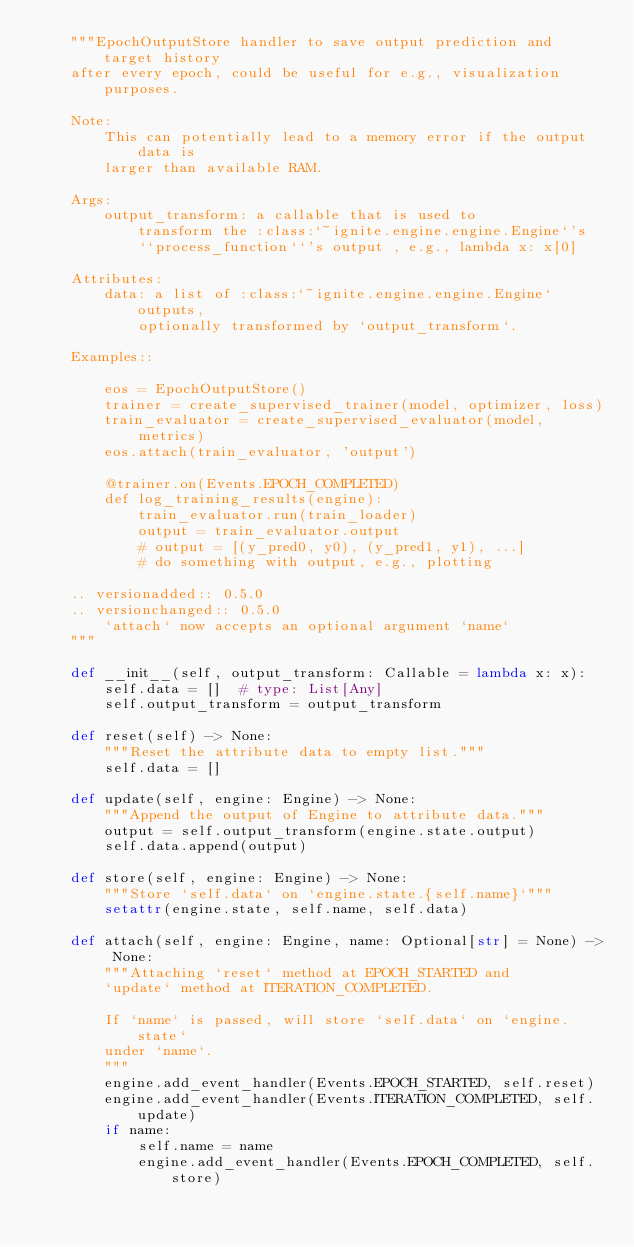<code> <loc_0><loc_0><loc_500><loc_500><_Python_>    """EpochOutputStore handler to save output prediction and target history
    after every epoch, could be useful for e.g., visualization purposes.

    Note:
        This can potentially lead to a memory error if the output data is
        larger than available RAM.

    Args:
        output_transform: a callable that is used to
            transform the :class:`~ignite.engine.engine.Engine`'s
            ``process_function``'s output , e.g., lambda x: x[0]

    Attributes:
        data: a list of :class:`~ignite.engine.engine.Engine` outputs,
            optionally transformed by `output_transform`.

    Examples::

        eos = EpochOutputStore()
        trainer = create_supervised_trainer(model, optimizer, loss)
        train_evaluator = create_supervised_evaluator(model, metrics)
        eos.attach(train_evaluator, 'output')

        @trainer.on(Events.EPOCH_COMPLETED)
        def log_training_results(engine):
            train_evaluator.run(train_loader)
            output = train_evaluator.output
            # output = [(y_pred0, y0), (y_pred1, y1), ...]
            # do something with output, e.g., plotting

    .. versionadded:: 0.5.0
    .. versionchanged:: 0.5.0
        `attach` now accepts an optional argument `name`
    """

    def __init__(self, output_transform: Callable = lambda x: x):
        self.data = []  # type: List[Any]
        self.output_transform = output_transform

    def reset(self) -> None:
        """Reset the attribute data to empty list."""
        self.data = []

    def update(self, engine: Engine) -> None:
        """Append the output of Engine to attribute data."""
        output = self.output_transform(engine.state.output)
        self.data.append(output)

    def store(self, engine: Engine) -> None:
        """Store `self.data` on `engine.state.{self.name}`"""
        setattr(engine.state, self.name, self.data)

    def attach(self, engine: Engine, name: Optional[str] = None) -> None:
        """Attaching `reset` method at EPOCH_STARTED and
        `update` method at ITERATION_COMPLETED.

        If `name` is passed, will store `self.data` on `engine.state`
        under `name`.
        """
        engine.add_event_handler(Events.EPOCH_STARTED, self.reset)
        engine.add_event_handler(Events.ITERATION_COMPLETED, self.update)
        if name:
            self.name = name
            engine.add_event_handler(Events.EPOCH_COMPLETED, self.store)
</code> 